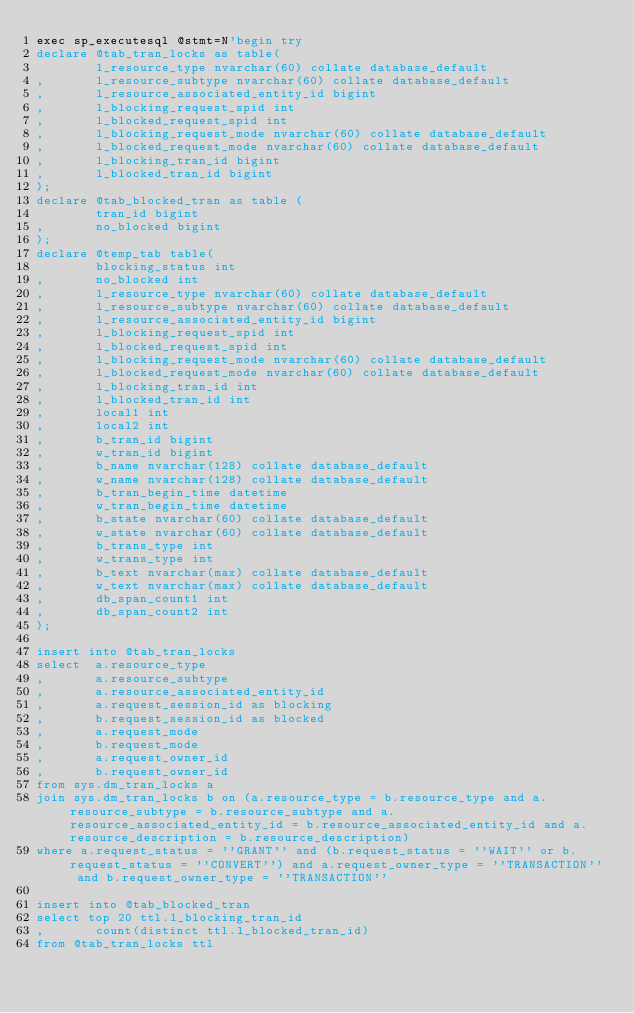<code> <loc_0><loc_0><loc_500><loc_500><_SQL_>exec sp_executesql @stmt=N'begin try
declare @tab_tran_locks as table(
        l_resource_type nvarchar(60) collate database_default 
,       l_resource_subtype nvarchar(60) collate database_default 
,       l_resource_associated_entity_id bigint
,       l_blocking_request_spid int
,       l_blocked_request_spid int
,       l_blocking_request_mode nvarchar(60) collate database_default 
,       l_blocked_request_mode nvarchar(60) collate database_default
,       l_blocking_tran_id bigint
,       l_blocked_tran_id bigint   
);
declare @tab_blocked_tran as table (
        tran_id bigint
,       no_blocked bigint
);
declare @temp_tab table(
        blocking_status int
,       no_blocked int
,       l_resource_type nvarchar(60) collate database_default 
,       l_resource_subtype nvarchar(60) collate database_default 
,       l_resource_associated_entity_id bigint
,       l_blocking_request_spid int
,       l_blocked_request_spid int
,       l_blocking_request_mode nvarchar(60) collate database_default 
,       l_blocked_request_mode nvarchar(60) collate database_default 
,       l_blocking_tran_id int
,       l_blocked_tran_id int   
,       local1 int
,       local2 int
,       b_tran_id bigint
,       w_tran_id bigint
,       b_name nvarchar(128) collate database_default 
,       w_name nvarchar(128) collate database_default 
,       b_tran_begin_time datetime
,       w_tran_begin_time datetime
,       b_state nvarchar(60) collate database_default 
,       w_state nvarchar(60) collate database_default 
,       b_trans_type int
,       w_trans_type int
,       b_text nvarchar(max) collate database_default 
,       w_text nvarchar(max) collate database_default 
,       db_span_count1 int
,       db_span_count2 int 
); 

insert into @tab_tran_locks 
select  a.resource_type
,       a.resource_subtype
,       a.resource_associated_entity_id
,       a.request_session_id as blocking 
,       b.request_session_id as blocked
,       a.request_mode
,       b.request_mode 
,       a.request_owner_id
,       b.request_owner_id  
from sys.dm_tran_locks a 
join sys.dm_tran_locks b on (a.resource_type = b.resource_type and a.resource_subtype = b.resource_subtype and a.resource_associated_entity_id = b.resource_associated_entity_id and a.resource_description = b.resource_description)
where a.request_status = ''GRANT'' and (b.request_status = ''WAIT'' or b.request_status = ''CONVERT'') and a.request_owner_type = ''TRANSACTION'' and b.request_owner_type = ''TRANSACTION''

insert into @tab_blocked_tran 
select top 20 ttl.l_blocking_tran_id
,       count(distinct ttl.l_blocked_tran_id)
from @tab_tran_locks ttl   </code> 